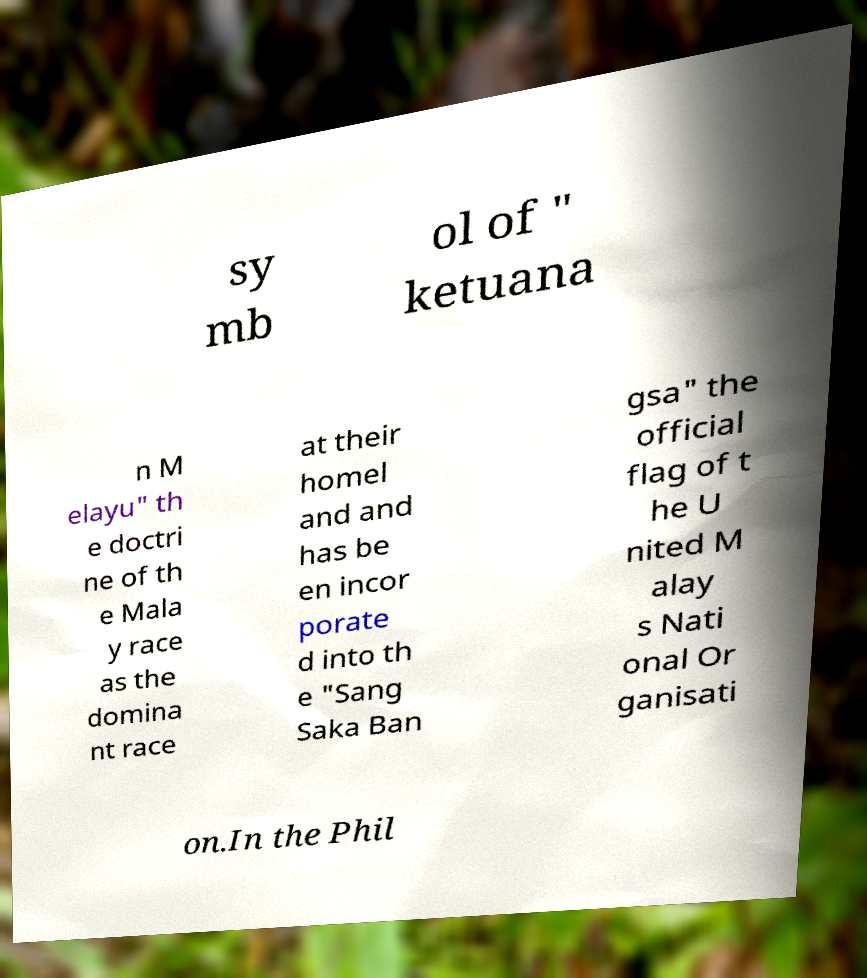I need the written content from this picture converted into text. Can you do that? sy mb ol of " ketuana n M elayu" th e doctri ne of th e Mala y race as the domina nt race at their homel and and has be en incor porate d into th e "Sang Saka Ban gsa" the official flag of t he U nited M alay s Nati onal Or ganisati on.In the Phil 